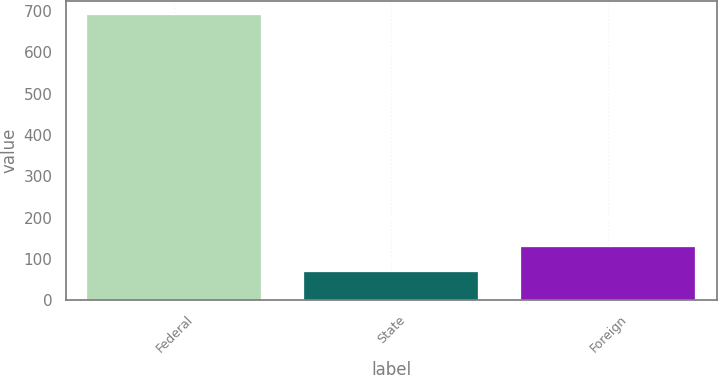Convert chart. <chart><loc_0><loc_0><loc_500><loc_500><bar_chart><fcel>Federal<fcel>State<fcel>Foreign<nl><fcel>691<fcel>68<fcel>130.3<nl></chart> 